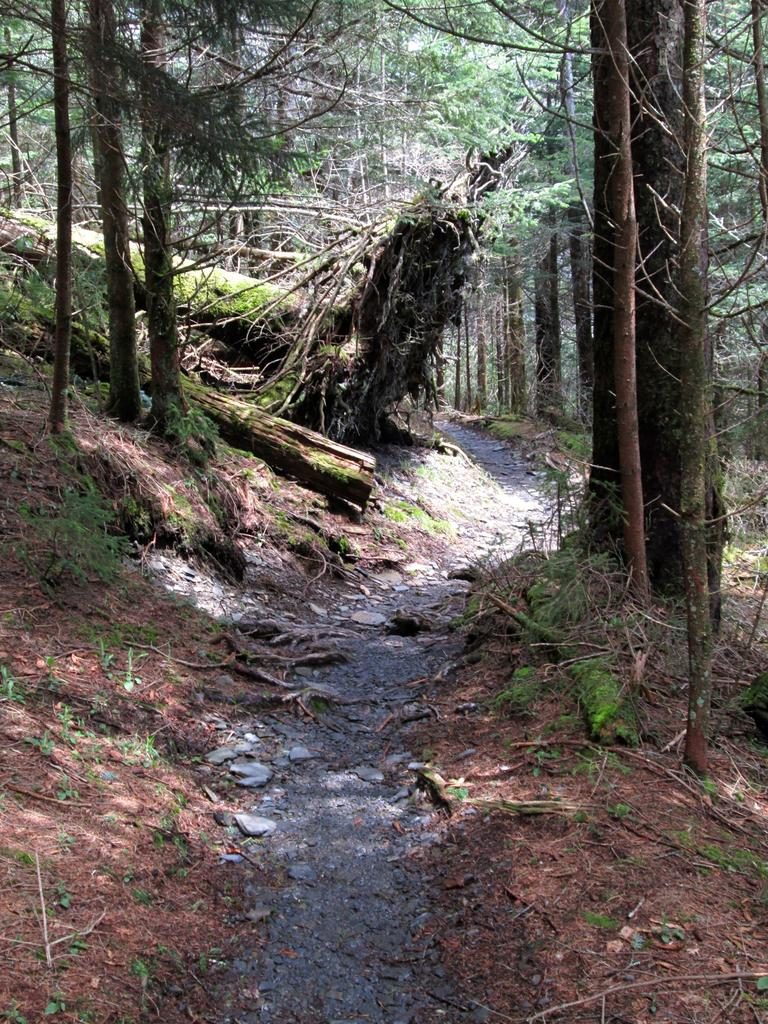What type of vegetation can be seen in the image? There are trees in the image. What is located at the center of the image? There is a path at the center of the image. What level of power does the hen have in the image? There is no hen present in the image, so it is not possible to determine its level of power. 